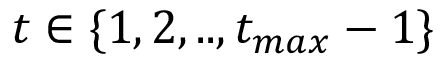<formula> <loc_0><loc_0><loc_500><loc_500>t \in \{ 1 , 2 , . . , t _ { \max } - 1 \}</formula> 